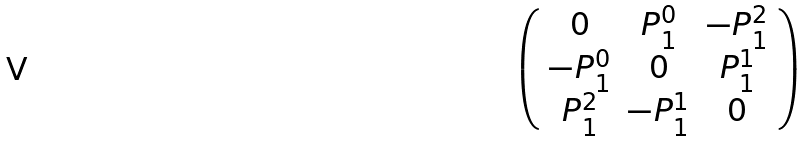Convert formula to latex. <formula><loc_0><loc_0><loc_500><loc_500>\left ( \begin{array} { c c c } 0 & P _ { 1 } ^ { 0 } & - P _ { 1 } ^ { 2 } \\ - P _ { 1 } ^ { 0 } & 0 & P _ { 1 } ^ { 1 } \\ P _ { 1 } ^ { 2 } & - P _ { 1 } ^ { 1 } & 0 \end{array} \right )</formula> 